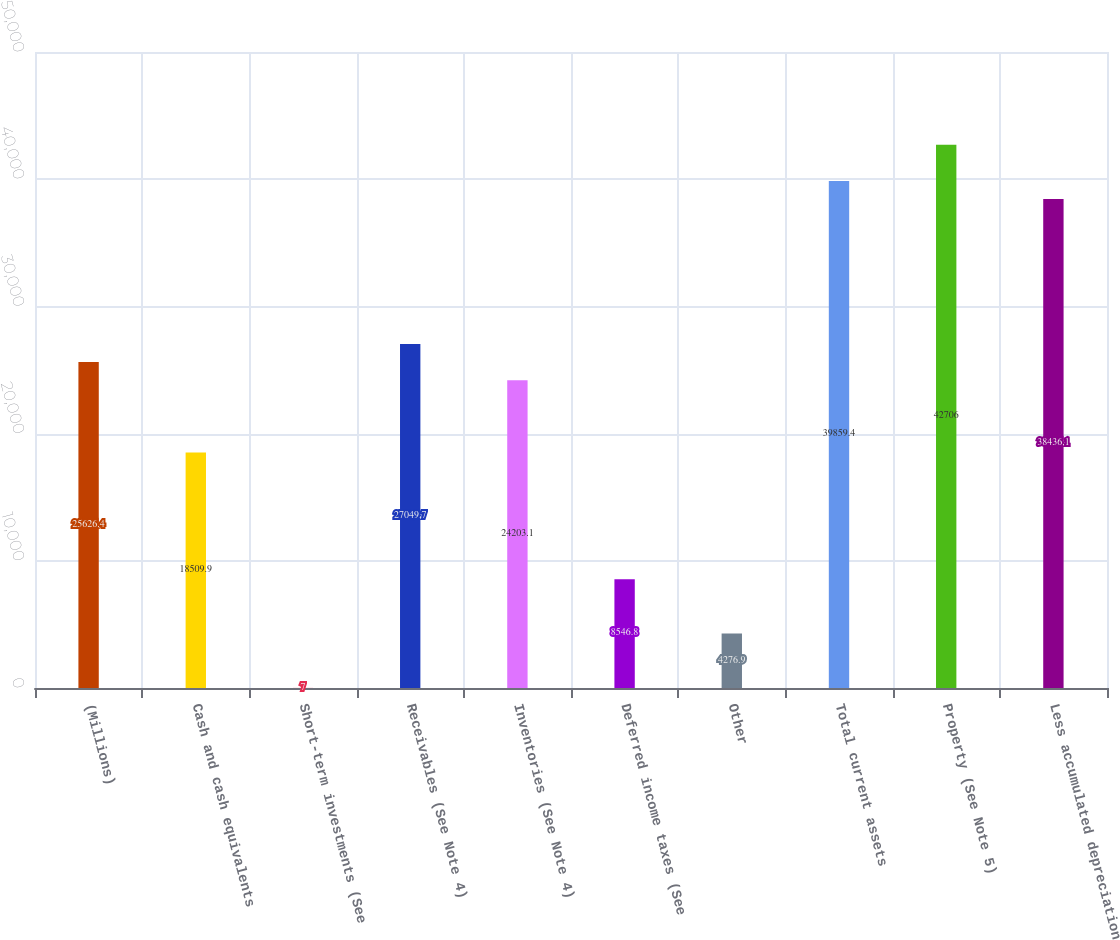Convert chart to OTSL. <chart><loc_0><loc_0><loc_500><loc_500><bar_chart><fcel>(Millions)<fcel>Cash and cash equivalents<fcel>Short-term investments (See<fcel>Receivables (See Note 4)<fcel>Inventories (See Note 4)<fcel>Deferred income taxes (See<fcel>Other<fcel>Total current assets<fcel>Property (See Note 5)<fcel>Less accumulated depreciation<nl><fcel>25626.4<fcel>18509.9<fcel>7<fcel>27049.7<fcel>24203.1<fcel>8546.8<fcel>4276.9<fcel>39859.4<fcel>42706<fcel>38436.1<nl></chart> 